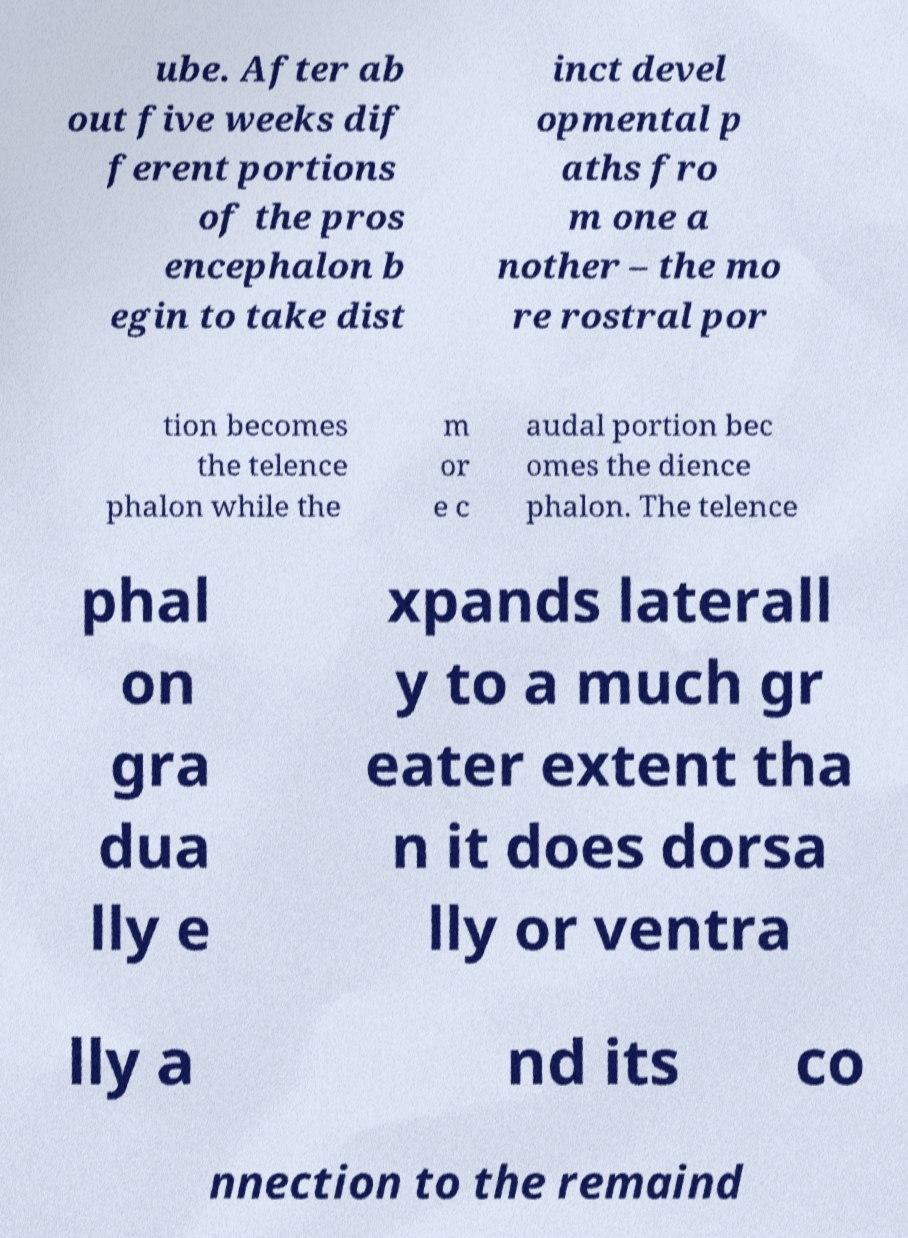Can you read and provide the text displayed in the image?This photo seems to have some interesting text. Can you extract and type it out for me? ube. After ab out five weeks dif ferent portions of the pros encephalon b egin to take dist inct devel opmental p aths fro m one a nother – the mo re rostral por tion becomes the telence phalon while the m or e c audal portion bec omes the dience phalon. The telence phal on gra dua lly e xpands laterall y to a much gr eater extent tha n it does dorsa lly or ventra lly a nd its co nnection to the remaind 